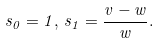<formula> <loc_0><loc_0><loc_500><loc_500>s _ { 0 } = 1 , \, s _ { 1 } = \frac { v - w } { w } .</formula> 